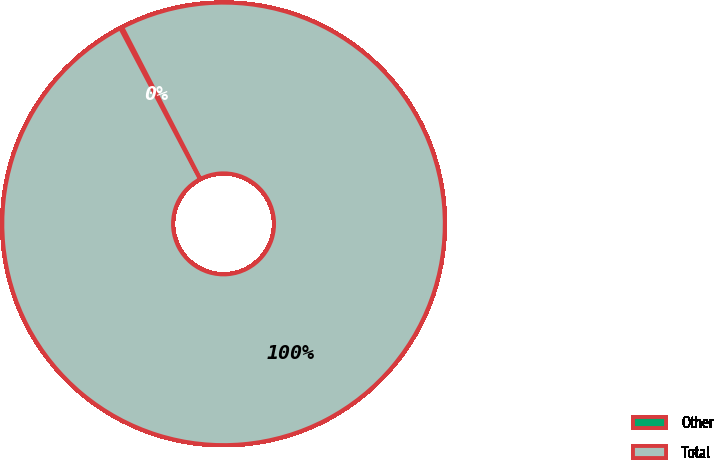<chart> <loc_0><loc_0><loc_500><loc_500><pie_chart><fcel>Other<fcel>Total<nl><fcel>0.16%<fcel>99.84%<nl></chart> 